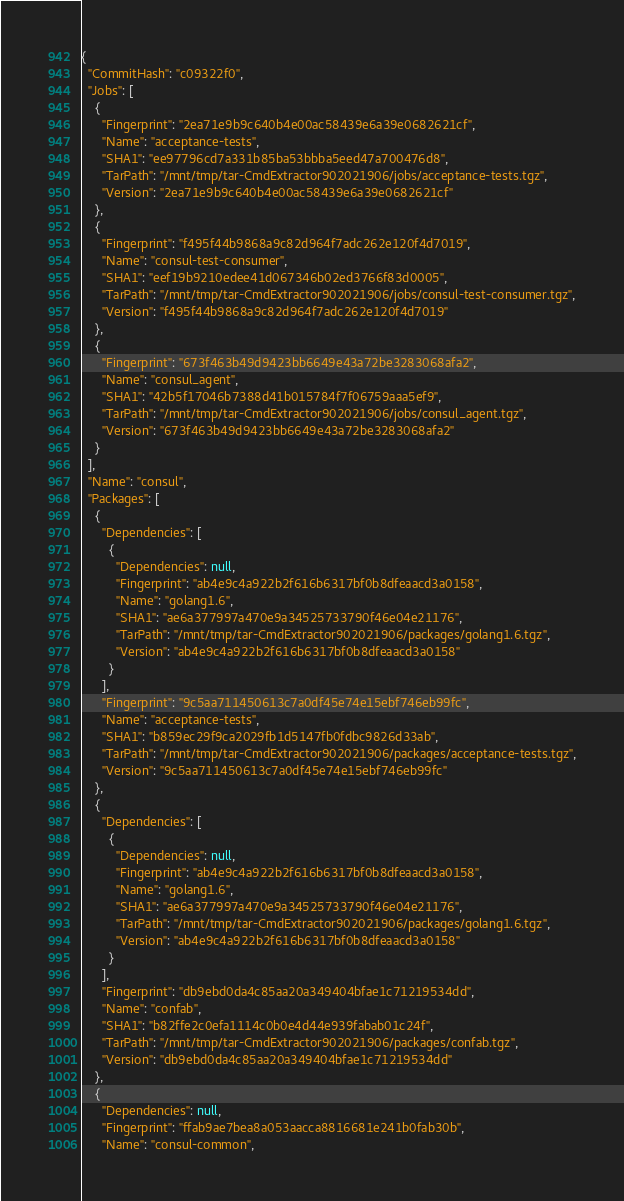<code> <loc_0><loc_0><loc_500><loc_500><_YAML_>{
  "CommitHash": "c09322f0",
  "Jobs": [
    {
      "Fingerprint": "2ea71e9b9c640b4e00ac58439e6a39e0682621cf",
      "Name": "acceptance-tests",
      "SHA1": "ee97796cd7a331b85ba53bbba5eed47a700476d8",
      "TarPath": "/mnt/tmp/tar-CmdExtractor902021906/jobs/acceptance-tests.tgz",
      "Version": "2ea71e9b9c640b4e00ac58439e6a39e0682621cf"
    },
    {
      "Fingerprint": "f495f44b9868a9c82d964f7adc262e120f4d7019",
      "Name": "consul-test-consumer",
      "SHA1": "eef19b9210edee41d067346b02ed3766f83d0005",
      "TarPath": "/mnt/tmp/tar-CmdExtractor902021906/jobs/consul-test-consumer.tgz",
      "Version": "f495f44b9868a9c82d964f7adc262e120f4d7019"
    },
    {
      "Fingerprint": "673f463b49d9423bb6649e43a72be3283068afa2",
      "Name": "consul_agent",
      "SHA1": "42b5f17046b7388d41b015784f7f06759aaa5ef9",
      "TarPath": "/mnt/tmp/tar-CmdExtractor902021906/jobs/consul_agent.tgz",
      "Version": "673f463b49d9423bb6649e43a72be3283068afa2"
    }
  ],
  "Name": "consul",
  "Packages": [
    {
      "Dependencies": [
        {
          "Dependencies": null,
          "Fingerprint": "ab4e9c4a922b2f616b6317bf0b8dfeaacd3a0158",
          "Name": "golang1.6",
          "SHA1": "ae6a377997a470e9a34525733790f46e04e21176",
          "TarPath": "/mnt/tmp/tar-CmdExtractor902021906/packages/golang1.6.tgz",
          "Version": "ab4e9c4a922b2f616b6317bf0b8dfeaacd3a0158"
        }
      ],
      "Fingerprint": "9c5aa711450613c7a0df45e74e15ebf746eb99fc",
      "Name": "acceptance-tests",
      "SHA1": "b859ec29f9ca2029fb1d5147fb0fdbc9826d33ab",
      "TarPath": "/mnt/tmp/tar-CmdExtractor902021906/packages/acceptance-tests.tgz",
      "Version": "9c5aa711450613c7a0df45e74e15ebf746eb99fc"
    },
    {
      "Dependencies": [
        {
          "Dependencies": null,
          "Fingerprint": "ab4e9c4a922b2f616b6317bf0b8dfeaacd3a0158",
          "Name": "golang1.6",
          "SHA1": "ae6a377997a470e9a34525733790f46e04e21176",
          "TarPath": "/mnt/tmp/tar-CmdExtractor902021906/packages/golang1.6.tgz",
          "Version": "ab4e9c4a922b2f616b6317bf0b8dfeaacd3a0158"
        }
      ],
      "Fingerprint": "db9ebd0da4c85aa20a349404bfae1c71219534dd",
      "Name": "confab",
      "SHA1": "b82ffe2c0efa1114c0b0e4d44e939fabab01c24f",
      "TarPath": "/mnt/tmp/tar-CmdExtractor902021906/packages/confab.tgz",
      "Version": "db9ebd0da4c85aa20a349404bfae1c71219534dd"
    },
    {
      "Dependencies": null,
      "Fingerprint": "ffab9ae7bea8a053aacca8816681e241b0fab30b",
      "Name": "consul-common",</code> 